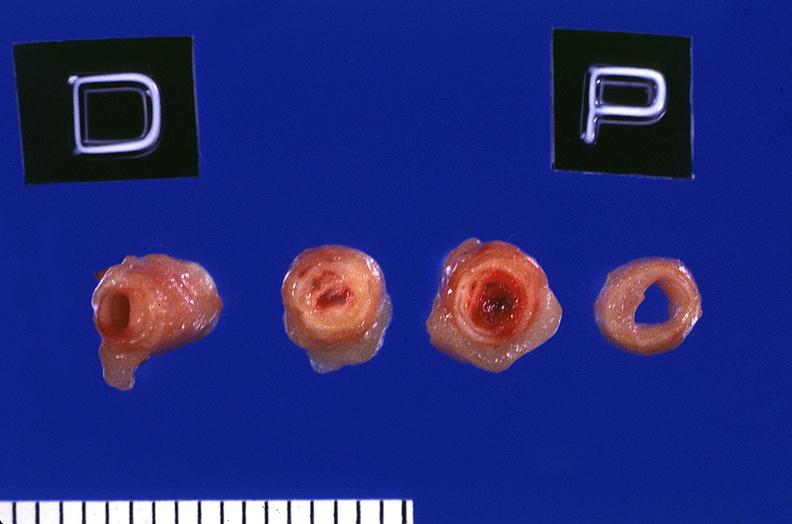what is present?
Answer the question using a single word or phrase. Cardiovascular 